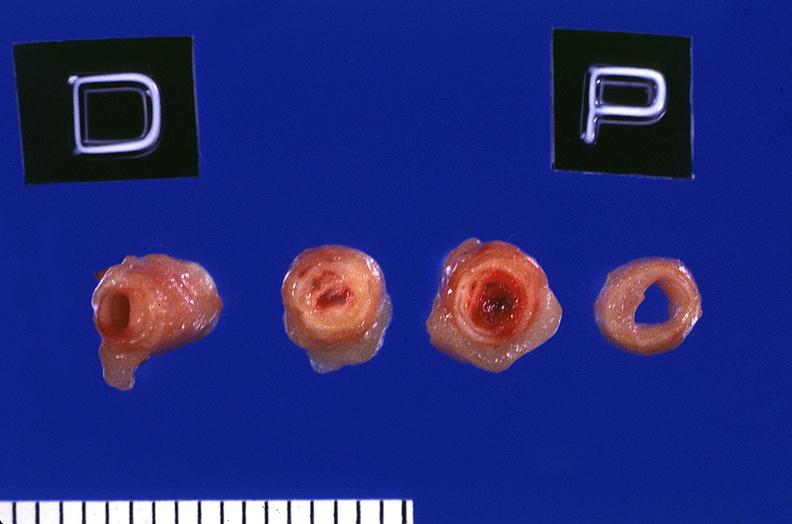what is present?
Answer the question using a single word or phrase. Cardiovascular 